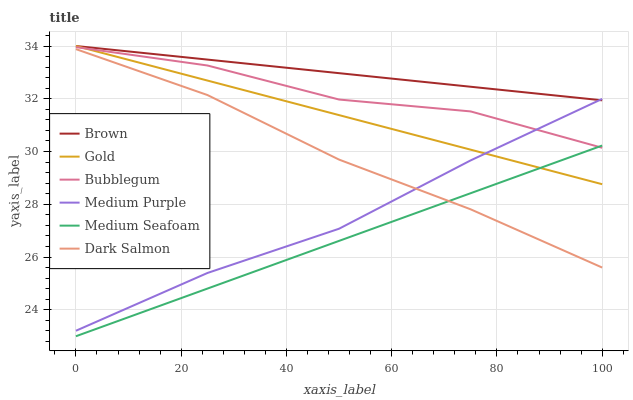Does Medium Seafoam have the minimum area under the curve?
Answer yes or no. Yes. Does Brown have the maximum area under the curve?
Answer yes or no. Yes. Does Gold have the minimum area under the curve?
Answer yes or no. No. Does Gold have the maximum area under the curve?
Answer yes or no. No. Is Medium Seafoam the smoothest?
Answer yes or no. Yes. Is Bubblegum the roughest?
Answer yes or no. Yes. Is Gold the smoothest?
Answer yes or no. No. Is Gold the roughest?
Answer yes or no. No. Does Medium Seafoam have the lowest value?
Answer yes or no. Yes. Does Gold have the lowest value?
Answer yes or no. No. Does Gold have the highest value?
Answer yes or no. Yes. Does Dark Salmon have the highest value?
Answer yes or no. No. Is Dark Salmon less than Bubblegum?
Answer yes or no. Yes. Is Brown greater than Medium Seafoam?
Answer yes or no. Yes. Does Medium Purple intersect Brown?
Answer yes or no. Yes. Is Medium Purple less than Brown?
Answer yes or no. No. Is Medium Purple greater than Brown?
Answer yes or no. No. Does Dark Salmon intersect Bubblegum?
Answer yes or no. No. 